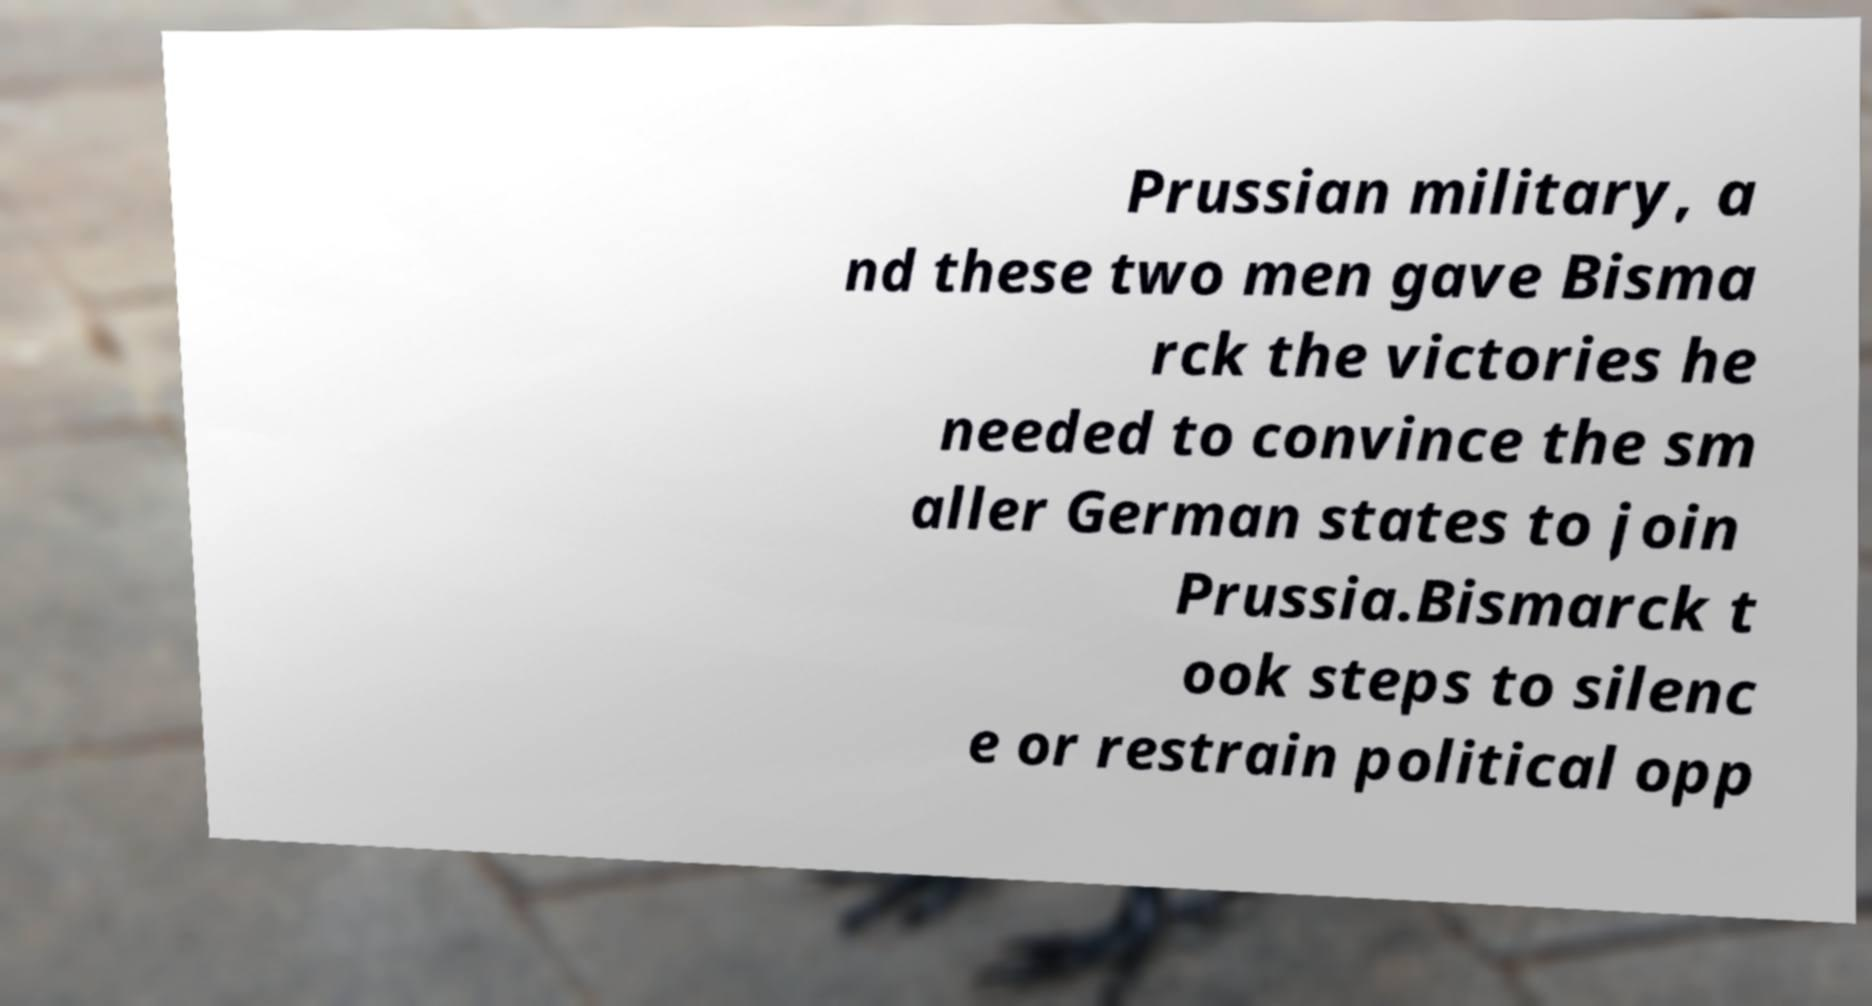Please identify and transcribe the text found in this image. Prussian military, a nd these two men gave Bisma rck the victories he needed to convince the sm aller German states to join Prussia.Bismarck t ook steps to silenc e or restrain political opp 